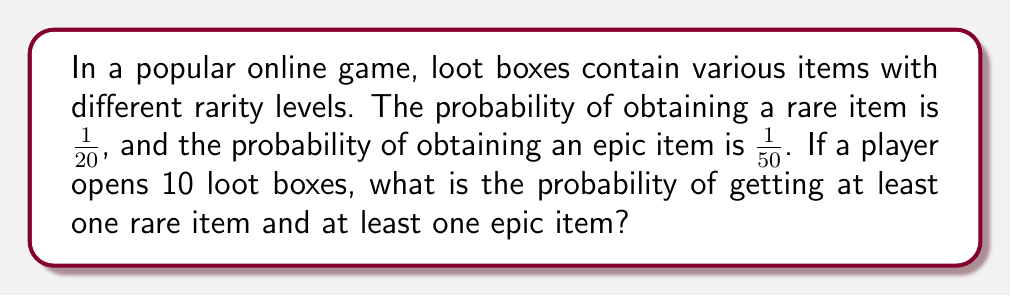What is the answer to this math problem? Let's approach this step-by-step:

1) First, let's calculate the probability of not getting a rare item in a single loot box:
   $P(\text{no rare}) = 1 - \frac{1}{20} = \frac{19}{20}$

2) The probability of not getting a rare item in 10 loot boxes:
   $P(\text{no rare in 10}) = (\frac{19}{20})^{10}$

3) Therefore, the probability of getting at least one rare item in 10 loot boxes:
   $P(\text{at least one rare}) = 1 - (\frac{19}{20})^{10}$

4) Similarly for epic items:
   $P(\text{no epic}) = 1 - \frac{1}{50} = \frac{49}{50}$
   $P(\text{no epic in 10}) = (\frac{49}{50})^{10}$
   $P(\text{at least one epic}) = 1 - (\frac{49}{50})^{10}$

5) The probability of getting at least one rare AND at least one epic is the product of these probabilities:

   $P(\text{at least one rare and one epic}) = [1 - (\frac{19}{20})^{10}] \times [1 - (\frac{49}{50})^{10}]$

6) Calculating this:
   $= [1 - 0.5987] \times [1 - 0.8179]$
   $= 0.4013 \times 0.1821$
   $= 0.0731$

7) Converting to a percentage:
   $0.0731 \times 100\% = 7.31\%$
Answer: 7.31% 